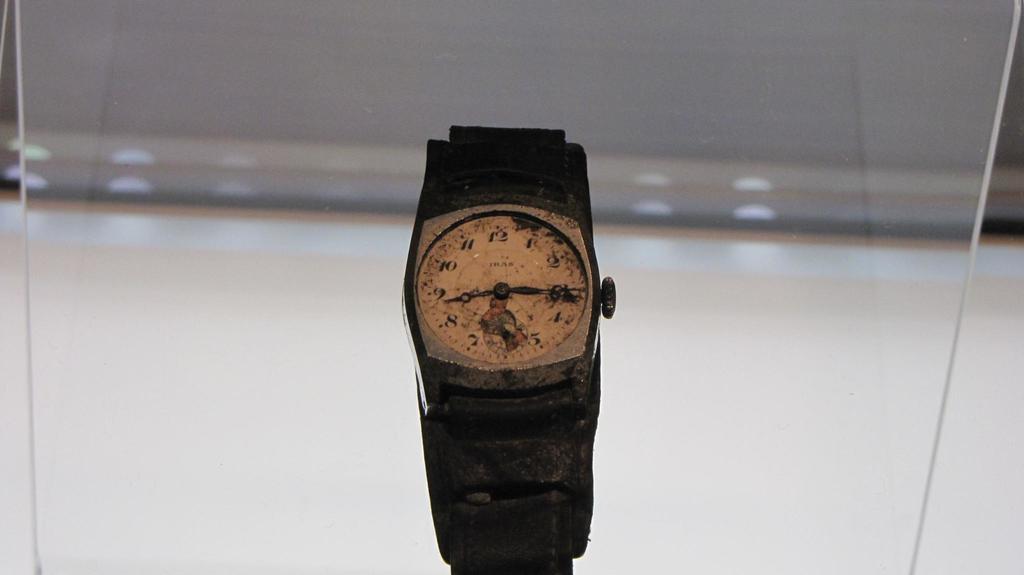What time is the watch set for?
Offer a terse response. 8:15. What is the top number on the watch?
Make the answer very short. 12. 